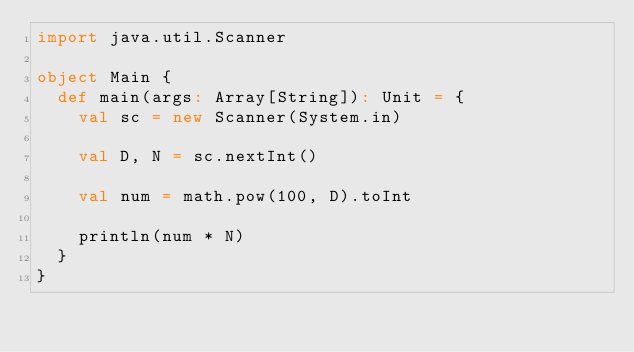Convert code to text. <code><loc_0><loc_0><loc_500><loc_500><_Scala_>import java.util.Scanner

object Main {
  def main(args: Array[String]): Unit = {
    val sc = new Scanner(System.in)

    val D, N = sc.nextInt()

    val num = math.pow(100, D).toInt

    println(num * N)
  }
}
</code> 